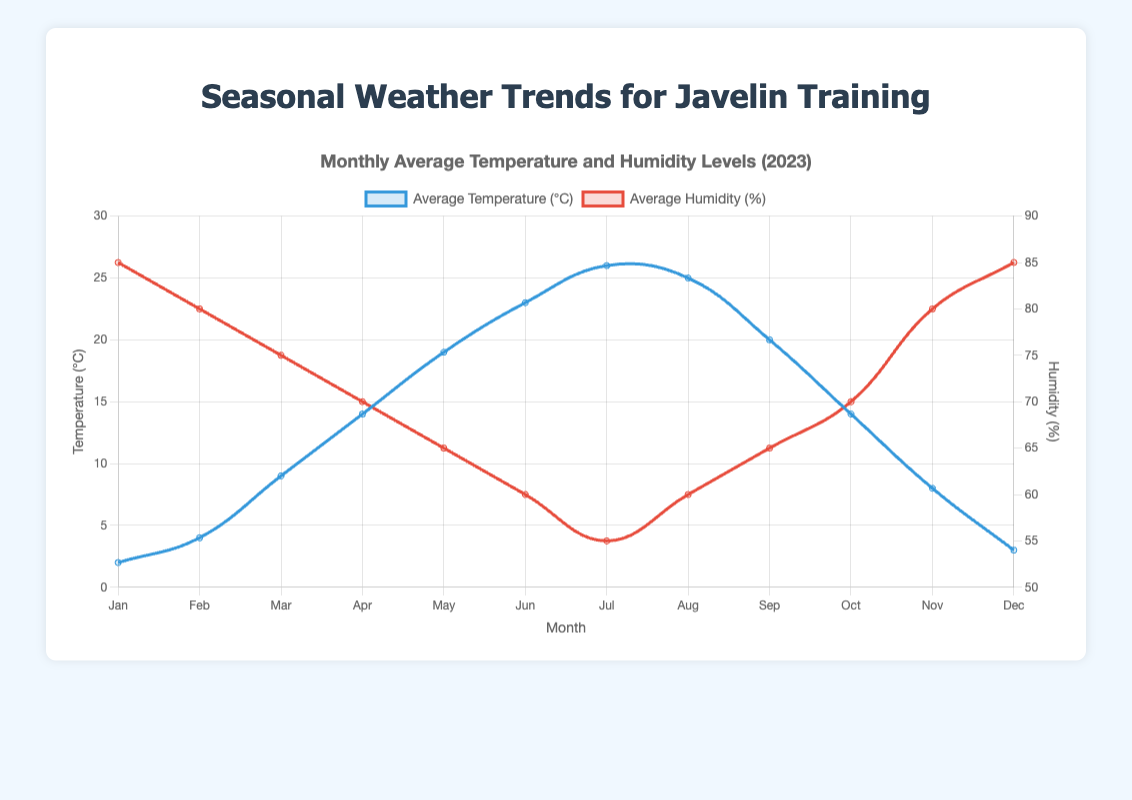What's the highest average temperature recorded? The highest point on the "Average Temperature (°C)" line is in July, where it shows 26°C.
Answer: 26°C Which month has the lowest average humidity? By examining the "Average Humidity (%)" line, the lowest point is in July with 55%.
Answer: July How much did the average temperature increase from January to July? The average temperature in January is 2°C, and in July it is 26°C. So, the increase is 26°C - 2°C = 24°C.
Answer: 24°C What is the combined average humidity for June and July? The average humidity in June is 60%, and in July it is 55%. Combined, it is (60 + 55) / 2 = 57.5%.
Answer: 57.5% Compare the average temperature in October and April. Which month is warmer? The average temperature in October is 14°C, and in April, it is also 14°C. Therefore, both months have the same temperature.
Answer: Both are the same Which month experiences a significant drop in average temperature from the previous month? Looking at the line chart for "Average Temperature (°C)," the temperature drops significantly from September (20°C) to October (14°C), a difference of 6°C.
Answer: October What is the average temperature difference between the two months with the highest temperatures? The highest temperatures are in July (26°C) and August (25°C). The difference is 26°C - 25°C = 1°C.
Answer: 1°C How many months have an average humidity level of 70% or higher? From the "Average Humidity (%)" line, the months with 70% or higher are January, February, March, October, November, and December. That's six months.
Answer: 6 months 